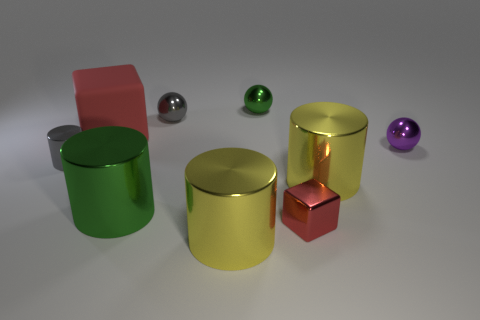Is the number of red metal cubes behind the tiny red block less than the number of objects that are in front of the small purple object?
Ensure brevity in your answer.  Yes. The big matte cube has what color?
Ensure brevity in your answer.  Red. Is there a large matte object of the same color as the tiny cylinder?
Offer a very short reply. No. The green metallic object that is right of the green metal thing that is in front of the small purple ball that is on the right side of the large green cylinder is what shape?
Your answer should be compact. Sphere. What is the material of the tiny purple ball that is behind the large green metallic cylinder?
Provide a succinct answer. Metal. What is the size of the red cube in front of the block that is to the left of the red thing right of the rubber thing?
Your response must be concise. Small. There is a purple shiny thing; does it have the same size as the yellow cylinder that is to the right of the small red object?
Your answer should be very brief. No. What color is the metallic thing that is left of the big block?
Provide a short and direct response. Gray. There is a large thing that is the same color as the tiny metal cube; what shape is it?
Keep it short and to the point. Cube. There is a green object behind the small gray cylinder; what shape is it?
Your response must be concise. Sphere. 